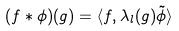Convert formula to latex. <formula><loc_0><loc_0><loc_500><loc_500>( f * \phi ) ( g ) = \langle f , \lambda _ { l } ( g ) \tilde { \phi } \rangle</formula> 